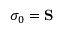Convert formula to latex. <formula><loc_0><loc_0><loc_500><loc_500>\sigma _ { 0 } = S</formula> 